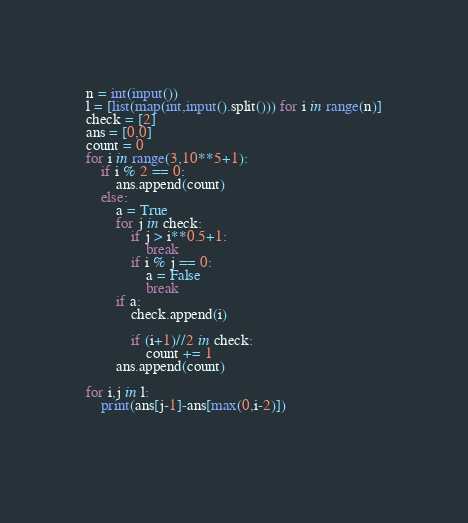<code> <loc_0><loc_0><loc_500><loc_500><_Python_>n = int(input())
l = [list(map(int,input().split())) for i in range(n)]
check = [2]
ans = [0,0]
count = 0
for i in range(3,10**5+1):
    if i % 2 == 0:
        ans.append(count)
    else:
        a = True
        for j in check:
            if j > i**0.5+1:
                break
            if i % j == 0:
                a = False
                break
        if a:
            check.append(i)
            
            if (i+1)//2 in check:  
                count += 1
        ans.append(count)

for i,j in l:
    print(ans[j-1]-ans[max(0,i-2)])
                
    
</code> 